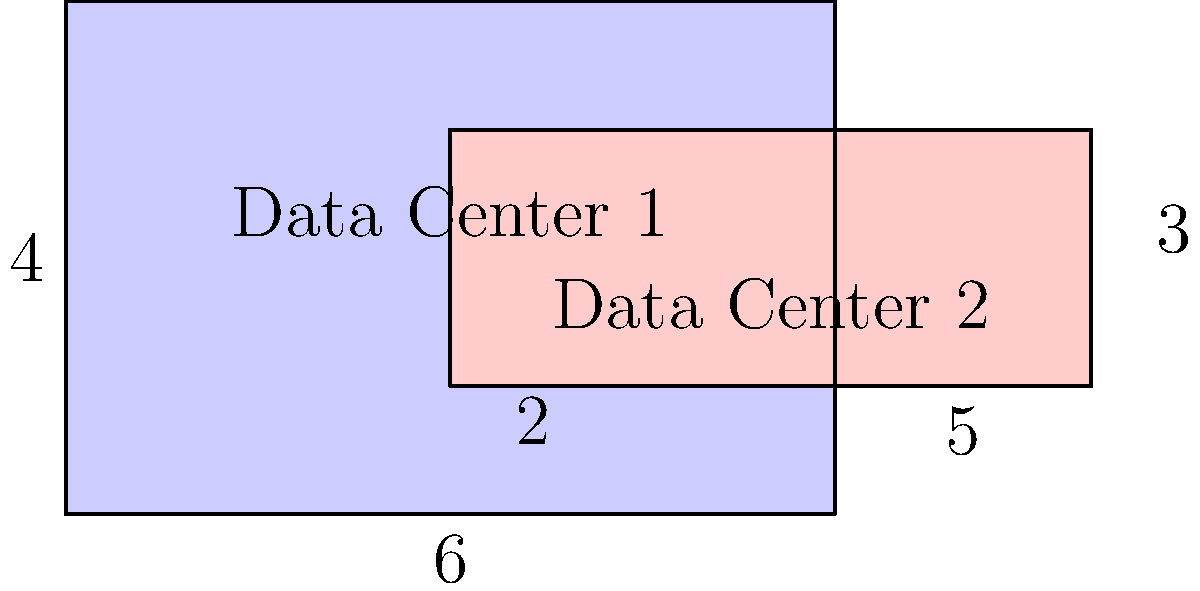As the CTO of a social media platform, you're optimizing data storage across two data centers. Data Center 1 is represented by a $6 \times 4$ rectangle, and Data Center 2 by a $5 \times 2$ rectangle. The rectangles overlap as shown in the diagram. If the overlapping area represents redundant data storage, what percentage of the total storage area is efficiently utilized (non-redundant)? Let's approach this step-by-step:

1) Calculate the area of Data Center 1:
   $A_1 = 6 \times 4 = 24$ square units

2) Calculate the area of Data Center 2:
   $A_2 = 5 \times 2 = 10$ square units

3) Calculate the total area of both data centers:
   $A_{total} = A_1 + A_2 = 24 + 10 = 34$ square units

4) Calculate the overlapping area:
   The overlap is $3 \times 2 = 6$ square units

5) Calculate the non-redundant area:
   $A_{non-redundant} = A_{total} - A_{overlap} = 34 - 6 = 28$ square units

6) Calculate the percentage of efficiently utilized storage:
   $\text{Efficiency} = \frac{A_{non-redundant}}{A_{total}} \times 100\%$
   $= \frac{28}{34} \times 100\% \approx 82.35\%$

Therefore, approximately 82.35% of the total storage area is efficiently utilized.
Answer: 82.35% 